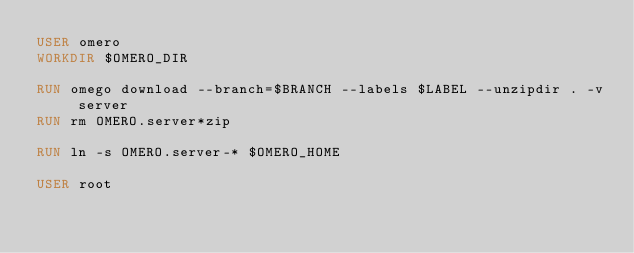<code> <loc_0><loc_0><loc_500><loc_500><_Dockerfile_>USER omero
WORKDIR $OMERO_DIR

RUN omego download --branch=$BRANCH --labels $LABEL --unzipdir . -v server
RUN rm OMERO.server*zip

RUN ln -s OMERO.server-* $OMERO_HOME

USER root
</code> 